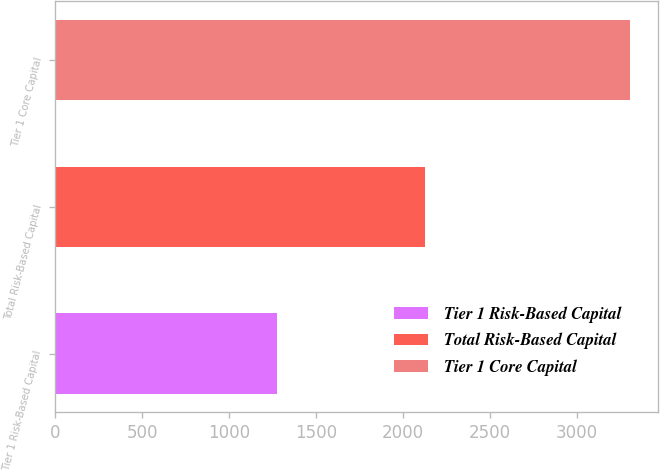<chart> <loc_0><loc_0><loc_500><loc_500><bar_chart><fcel>Tier 1 Risk-Based Capital<fcel>Total Risk-Based Capital<fcel>Tier 1 Core Capital<nl><fcel>1276<fcel>2126<fcel>3302<nl></chart> 